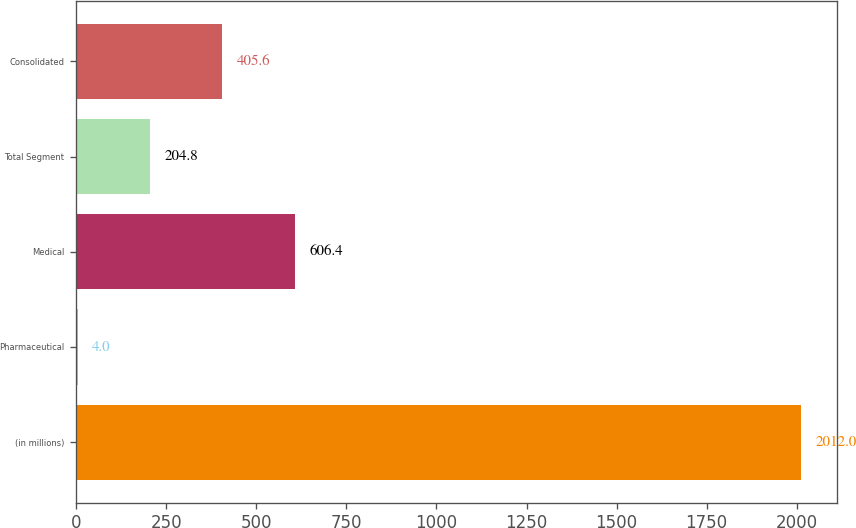<chart> <loc_0><loc_0><loc_500><loc_500><bar_chart><fcel>(in millions)<fcel>Pharmaceutical<fcel>Medical<fcel>Total Segment<fcel>Consolidated<nl><fcel>2012<fcel>4<fcel>606.4<fcel>204.8<fcel>405.6<nl></chart> 